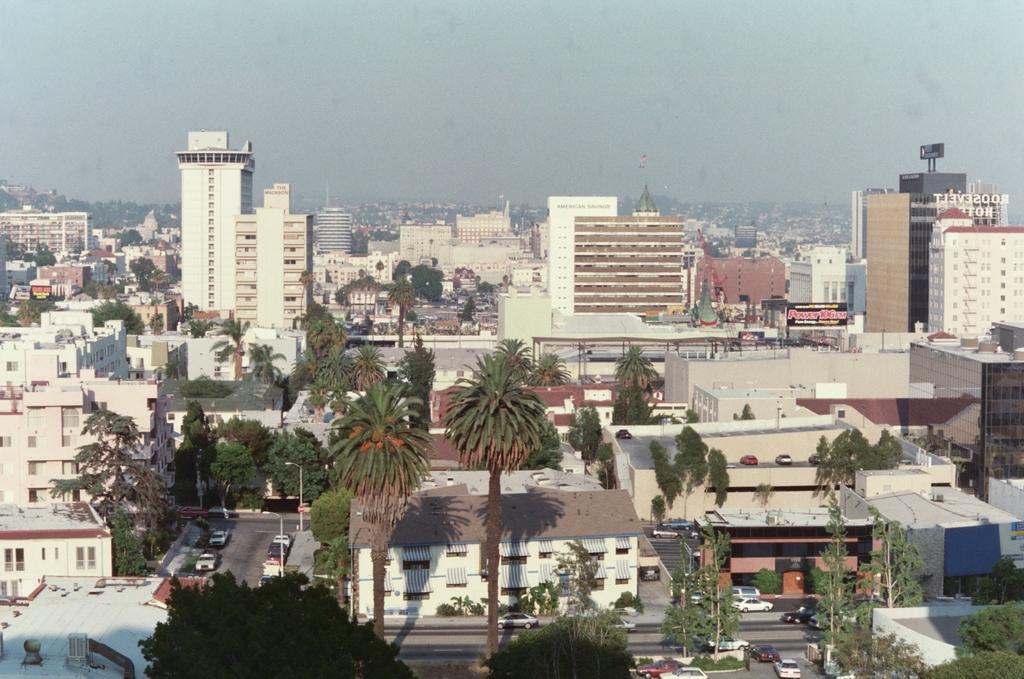Please provide a concise description of this image. In this image there are trees, buildings and vehicles and the sky is cloudy. 